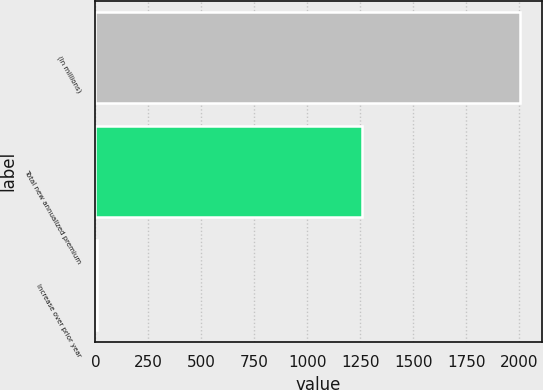<chart> <loc_0><loc_0><loc_500><loc_500><bar_chart><fcel>(In millions)<fcel>Total new annualized premium<fcel>Increase over prior year<nl><fcel>2005<fcel>1259<fcel>6.1<nl></chart> 